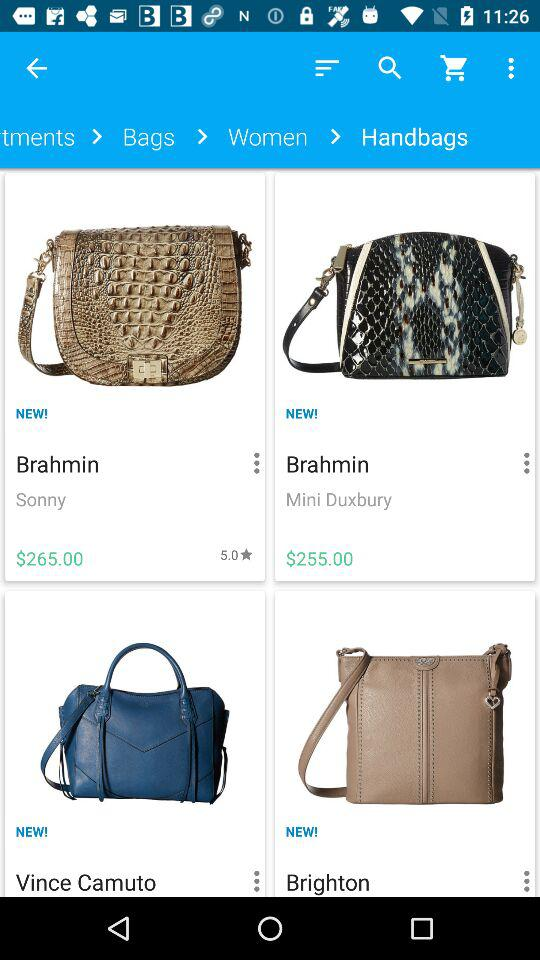How much more expensive is the Brahmin Mini Duxbury than the Vince Camuto handbag?
Answer the question using a single word or phrase. $10.00 